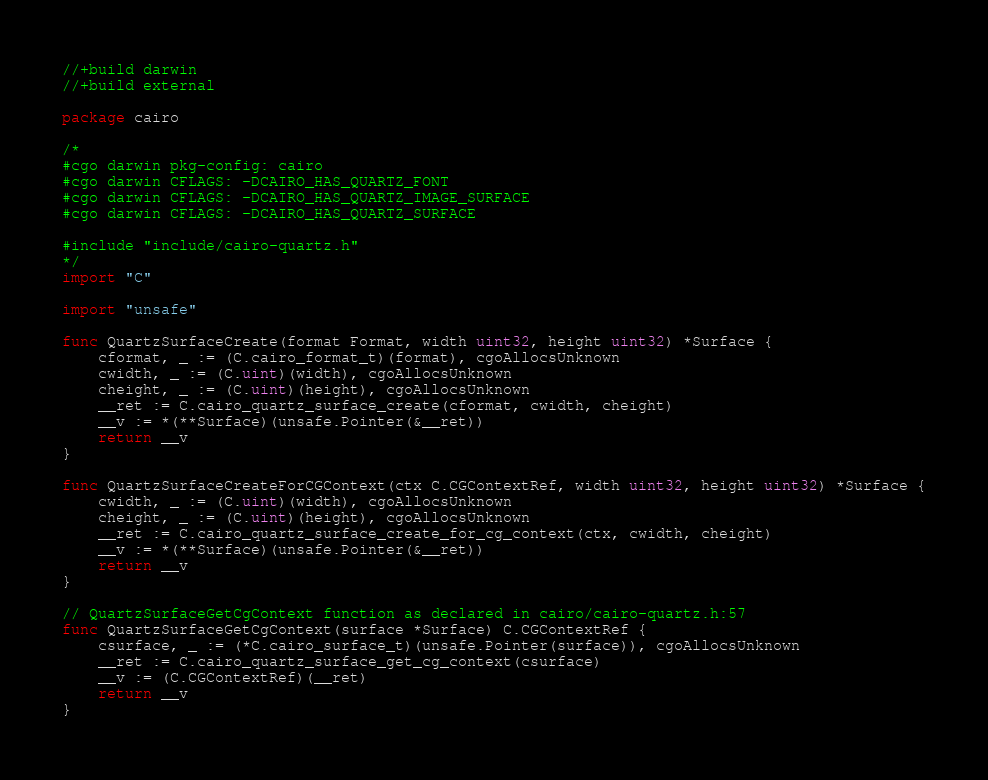Convert code to text. <code><loc_0><loc_0><loc_500><loc_500><_Go_>//+build darwin
//+build external

package cairo

/*
#cgo darwin pkg-config: cairo
#cgo darwin CFLAGS: -DCAIRO_HAS_QUARTZ_FONT
#cgo darwin CFLAGS: -DCAIRO_HAS_QUARTZ_IMAGE_SURFACE
#cgo darwin CFLAGS: -DCAIRO_HAS_QUARTZ_SURFACE

#include "include/cairo-quartz.h"
*/
import "C"

import "unsafe"

func QuartzSurfaceCreate(format Format, width uint32, height uint32) *Surface {
	cformat, _ := (C.cairo_format_t)(format), cgoAllocsUnknown
	cwidth, _ := (C.uint)(width), cgoAllocsUnknown
	cheight, _ := (C.uint)(height), cgoAllocsUnknown
	__ret := C.cairo_quartz_surface_create(cformat, cwidth, cheight)
	__v := *(**Surface)(unsafe.Pointer(&__ret))
	return __v
}

func QuartzSurfaceCreateForCGContext(ctx C.CGContextRef, width uint32, height uint32) *Surface {
	cwidth, _ := (C.uint)(width), cgoAllocsUnknown
	cheight, _ := (C.uint)(height), cgoAllocsUnknown
	__ret := C.cairo_quartz_surface_create_for_cg_context(ctx, cwidth, cheight)
	__v := *(**Surface)(unsafe.Pointer(&__ret))
	return __v
}

// QuartzSurfaceGetCgContext function as declared in cairo/cairo-quartz.h:57
func QuartzSurfaceGetCgContext(surface *Surface) C.CGContextRef {
	csurface, _ := (*C.cairo_surface_t)(unsafe.Pointer(surface)), cgoAllocsUnknown
	__ret := C.cairo_quartz_surface_get_cg_context(csurface)
	__v := (C.CGContextRef)(__ret)
	return __v
}
</code> 